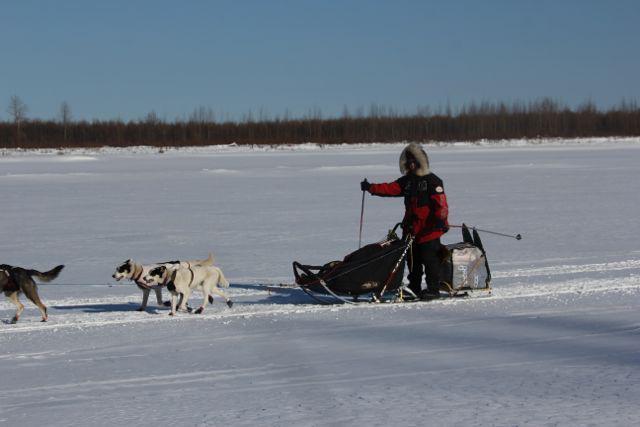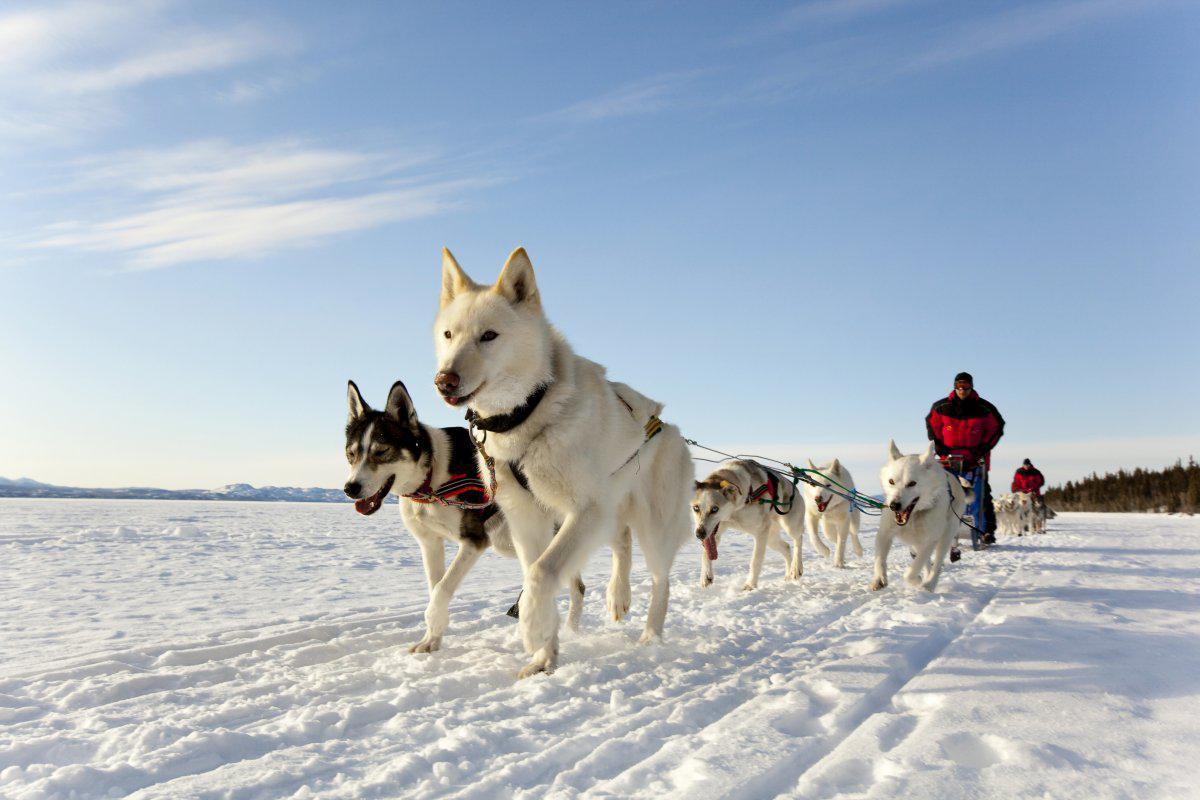The first image is the image on the left, the second image is the image on the right. Evaluate the accuracy of this statement regarding the images: "The sled dog team on the left heads leftward, and the dog team on the right heads rightward, and each team appears to be moving.". Is it true? Answer yes or no. No. 